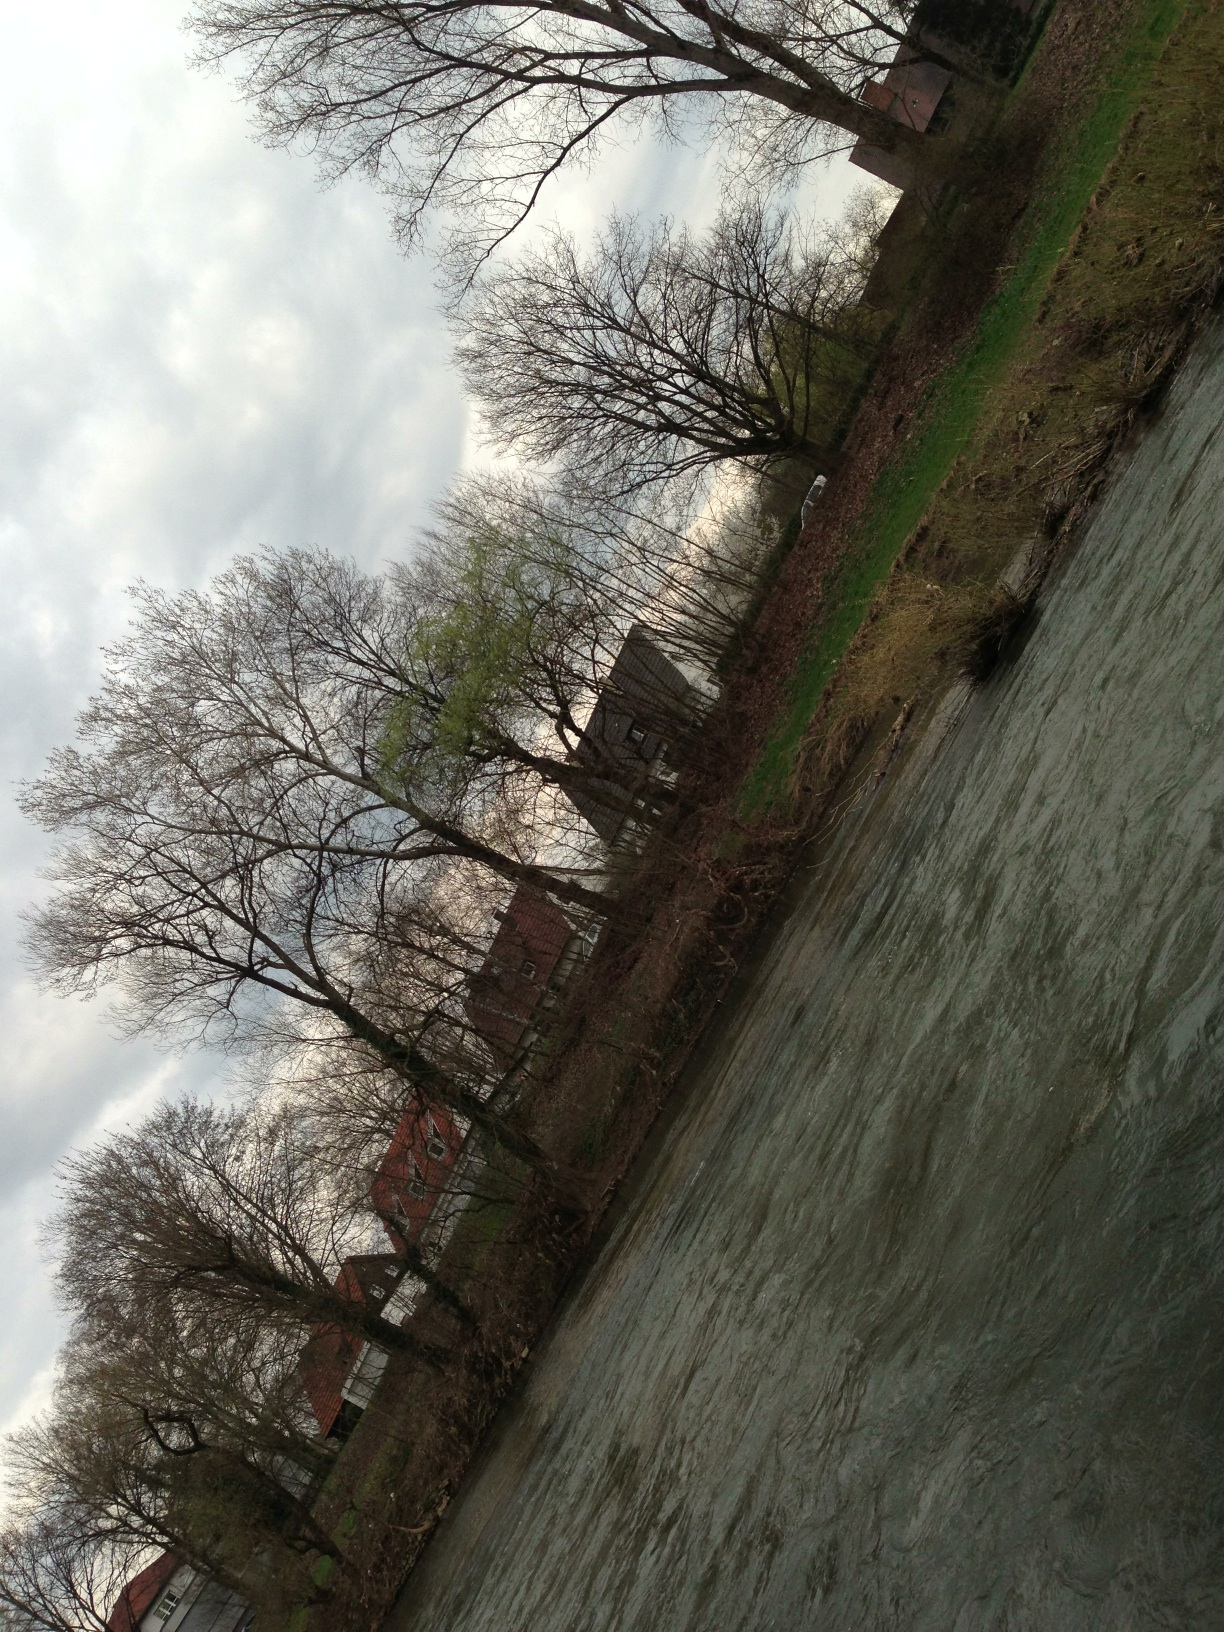What is it? The image depicts a lively river flowing swiftly, bordered by leafless trees on one side and a row of quaint houses on the other, giving a serene view of a rural or semi-urban area in what could be early spring. 